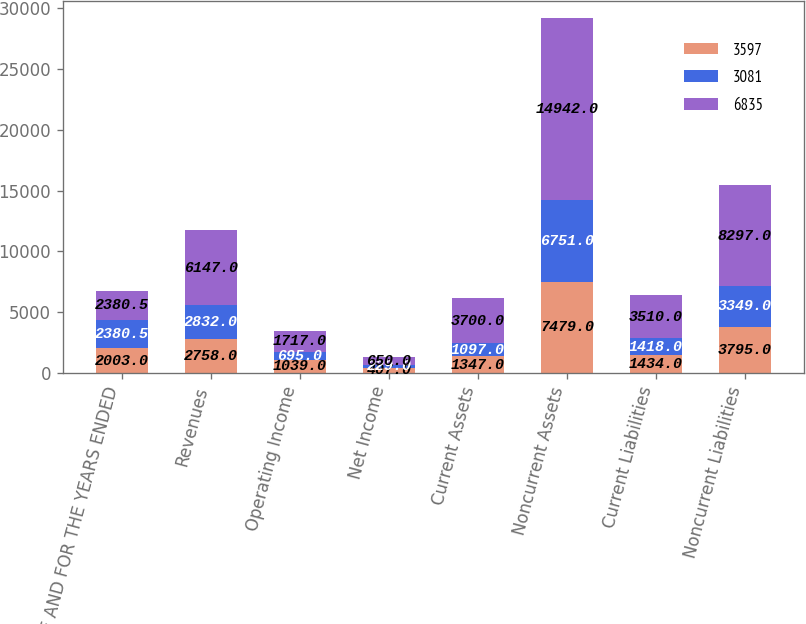Convert chart. <chart><loc_0><loc_0><loc_500><loc_500><stacked_bar_chart><ecel><fcel>AS OF AND FOR THE YEARS ENDED<fcel>Revenues<fcel>Operating Income<fcel>Net Income<fcel>Current Assets<fcel>Noncurrent Assets<fcel>Current Liabilities<fcel>Noncurrent Liabilities<nl><fcel>3597<fcel>2003<fcel>2758<fcel>1039<fcel>407<fcel>1347<fcel>7479<fcel>1434<fcel>3795<nl><fcel>3081<fcel>2380.5<fcel>2832<fcel>695<fcel>229<fcel>1097<fcel>6751<fcel>1418<fcel>3349<nl><fcel>6835<fcel>2380.5<fcel>6147<fcel>1717<fcel>650<fcel>3700<fcel>14942<fcel>3510<fcel>8297<nl></chart> 